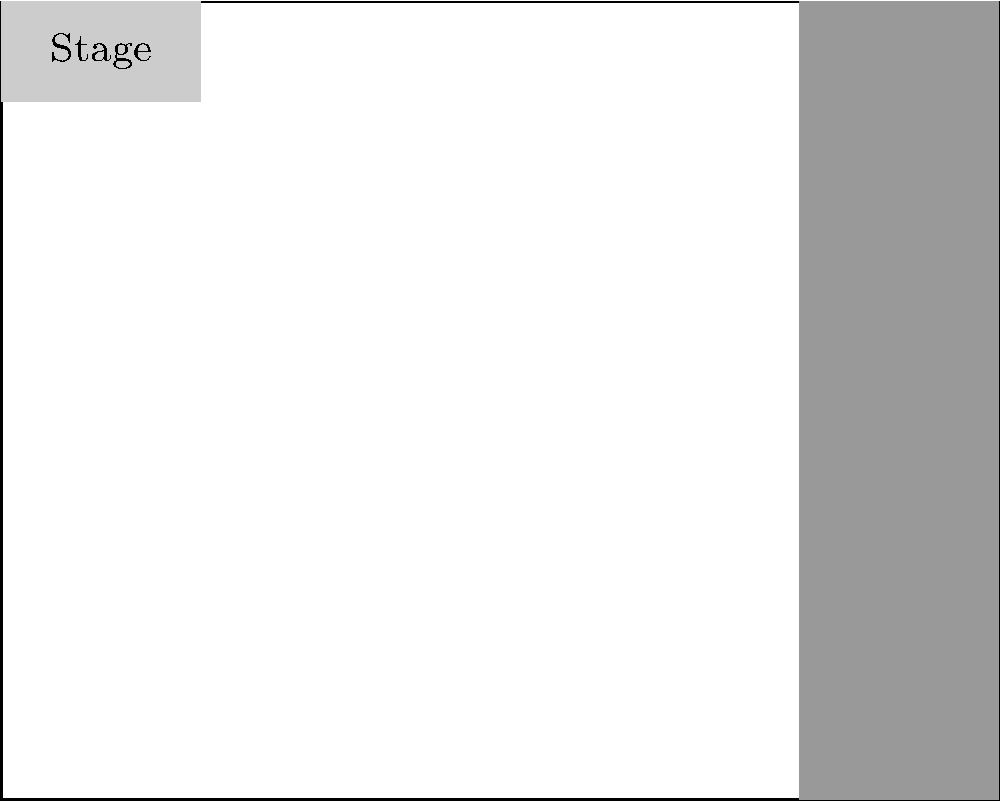Coach, we need to figure out how many students can fit in the gym for our big hockey pep rally! Given the floor plan of our school gym (20m x 16m), with a 2m deep stage at one end and bleachers taking up 2m along one side, how many students can we squeeze in if each student needs about 0.5 square meters of space? Let's round down to be safe - we don't want any penalty for too many players on the ice! Let's break this down step-by-step, just like we'd plan our hockey strategy:

1) First, let's calculate the total area of the gym:
   $$ \text{Total Area} = 20\text{m} \times 16\text{m} = 320\text{m}^2 $$

2) Now, we need to subtract the areas we can't use:
   - Stage area: $2\text{m} \times 20\text{m} = 40\text{m}^2$
   - Bleacher area: $2\text{m} \times 16\text{m} = 32\text{m}^2$

3) Let's calculate the usable area:
   $$ \text{Usable Area} = 320\text{m}^2 - 40\text{m}^2 - 32\text{m}^2 = 248\text{m}^2 $$

4) Each student needs 0.5 square meters, so we can calculate the number of students:
   $$ \text{Number of Students} = \frac{248\text{m}^2}{0.5\text{m}^2/\text{student}} = 496 \text{ students} $$

5) Rounding down for safety:
   $$ 496 \text{ students} \approx 490 \text{ students} $$

Therefore, we can safely fit 490 students in the gym for our pep rally!
Answer: 490 students 